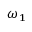<formula> <loc_0><loc_0><loc_500><loc_500>{ \omega } _ { 1 }</formula> 